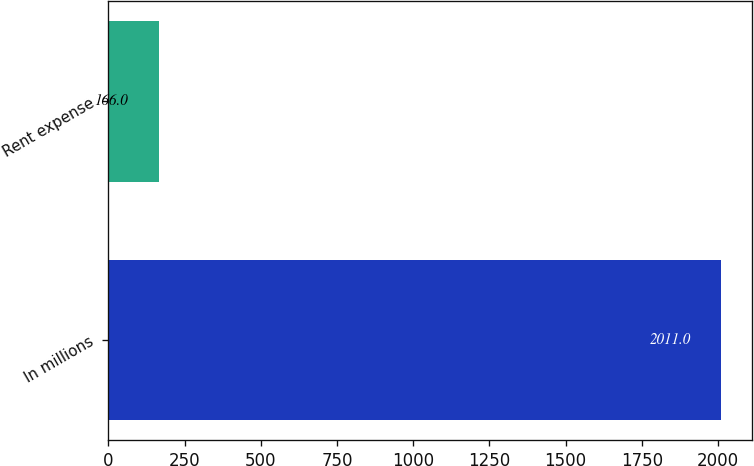<chart> <loc_0><loc_0><loc_500><loc_500><bar_chart><fcel>In millions<fcel>Rent expense<nl><fcel>2011<fcel>166<nl></chart> 